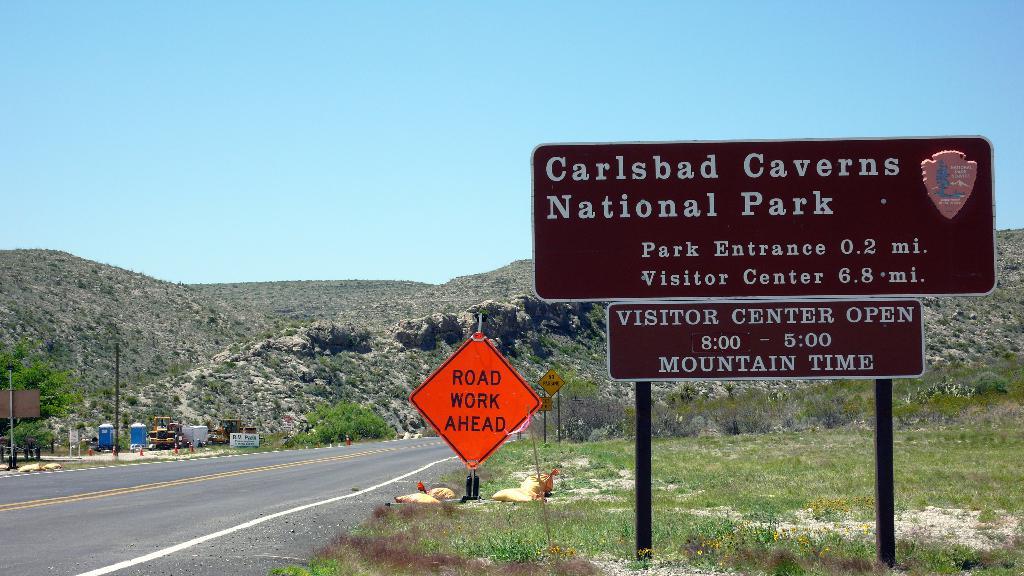What time does the visitor center open?
Give a very brief answer. 8:00. What is ahead on the road?
Offer a terse response. Road work. 